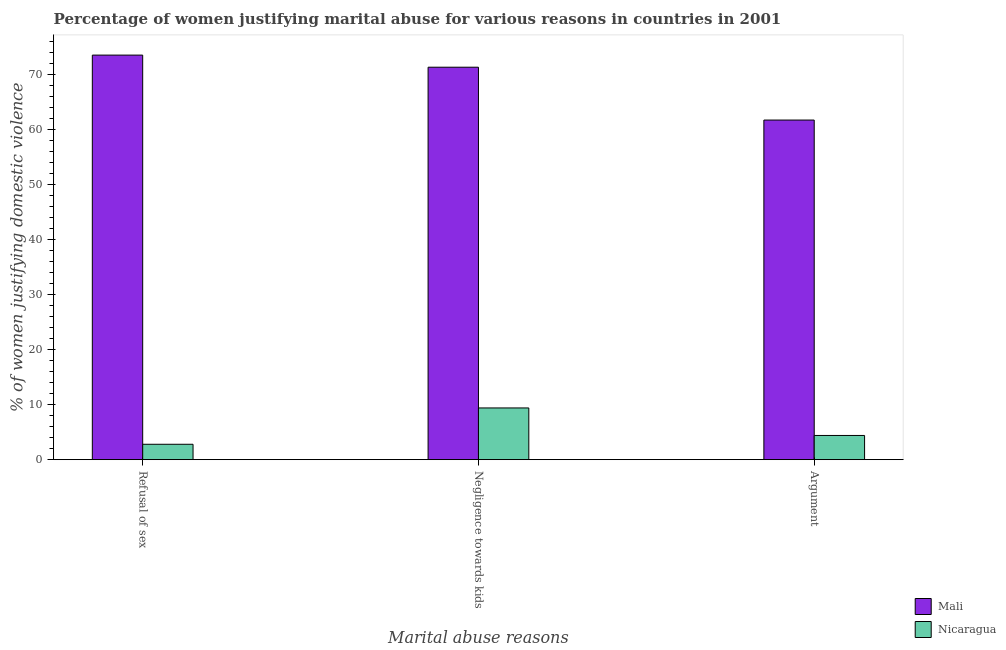Are the number of bars per tick equal to the number of legend labels?
Your response must be concise. Yes. How many bars are there on the 3rd tick from the right?
Provide a succinct answer. 2. What is the label of the 2nd group of bars from the left?
Your answer should be very brief. Negligence towards kids. What is the percentage of women justifying domestic violence due to negligence towards kids in Mali?
Your response must be concise. 71.3. Across all countries, what is the maximum percentage of women justifying domestic violence due to refusal of sex?
Your answer should be compact. 73.5. Across all countries, what is the minimum percentage of women justifying domestic violence due to arguments?
Keep it short and to the point. 4.4. In which country was the percentage of women justifying domestic violence due to refusal of sex maximum?
Provide a short and direct response. Mali. In which country was the percentage of women justifying domestic violence due to arguments minimum?
Your response must be concise. Nicaragua. What is the total percentage of women justifying domestic violence due to arguments in the graph?
Give a very brief answer. 66.1. What is the difference between the percentage of women justifying domestic violence due to negligence towards kids in Mali and that in Nicaragua?
Keep it short and to the point. 61.9. What is the difference between the percentage of women justifying domestic violence due to arguments in Mali and the percentage of women justifying domestic violence due to refusal of sex in Nicaragua?
Offer a terse response. 58.9. What is the average percentage of women justifying domestic violence due to negligence towards kids per country?
Give a very brief answer. 40.35. In how many countries, is the percentage of women justifying domestic violence due to negligence towards kids greater than 46 %?
Offer a terse response. 1. What is the ratio of the percentage of women justifying domestic violence due to arguments in Mali to that in Nicaragua?
Your answer should be compact. 14.02. What is the difference between the highest and the second highest percentage of women justifying domestic violence due to arguments?
Your answer should be compact. 57.3. What is the difference between the highest and the lowest percentage of women justifying domestic violence due to negligence towards kids?
Your response must be concise. 61.9. In how many countries, is the percentage of women justifying domestic violence due to refusal of sex greater than the average percentage of women justifying domestic violence due to refusal of sex taken over all countries?
Ensure brevity in your answer.  1. What does the 2nd bar from the left in Negligence towards kids represents?
Keep it short and to the point. Nicaragua. What does the 2nd bar from the right in Argument represents?
Your answer should be compact. Mali. Is it the case that in every country, the sum of the percentage of women justifying domestic violence due to refusal of sex and percentage of women justifying domestic violence due to negligence towards kids is greater than the percentage of women justifying domestic violence due to arguments?
Make the answer very short. Yes. How many countries are there in the graph?
Keep it short and to the point. 2. Does the graph contain grids?
Provide a short and direct response. No. Where does the legend appear in the graph?
Your answer should be compact. Bottom right. How are the legend labels stacked?
Keep it short and to the point. Vertical. What is the title of the graph?
Your response must be concise. Percentage of women justifying marital abuse for various reasons in countries in 2001. What is the label or title of the X-axis?
Make the answer very short. Marital abuse reasons. What is the label or title of the Y-axis?
Your answer should be very brief. % of women justifying domestic violence. What is the % of women justifying domestic violence of Mali in Refusal of sex?
Offer a terse response. 73.5. What is the % of women justifying domestic violence in Mali in Negligence towards kids?
Your response must be concise. 71.3. What is the % of women justifying domestic violence of Mali in Argument?
Your answer should be compact. 61.7. What is the % of women justifying domestic violence of Nicaragua in Argument?
Your response must be concise. 4.4. Across all Marital abuse reasons, what is the maximum % of women justifying domestic violence in Mali?
Keep it short and to the point. 73.5. Across all Marital abuse reasons, what is the minimum % of women justifying domestic violence in Mali?
Ensure brevity in your answer.  61.7. Across all Marital abuse reasons, what is the minimum % of women justifying domestic violence of Nicaragua?
Your answer should be compact. 2.8. What is the total % of women justifying domestic violence in Mali in the graph?
Offer a terse response. 206.5. What is the total % of women justifying domestic violence of Nicaragua in the graph?
Keep it short and to the point. 16.6. What is the difference between the % of women justifying domestic violence in Nicaragua in Refusal of sex and that in Argument?
Provide a succinct answer. -1.6. What is the difference between the % of women justifying domestic violence in Mali in Refusal of sex and the % of women justifying domestic violence in Nicaragua in Negligence towards kids?
Make the answer very short. 64.1. What is the difference between the % of women justifying domestic violence in Mali in Refusal of sex and the % of women justifying domestic violence in Nicaragua in Argument?
Give a very brief answer. 69.1. What is the difference between the % of women justifying domestic violence in Mali in Negligence towards kids and the % of women justifying domestic violence in Nicaragua in Argument?
Provide a succinct answer. 66.9. What is the average % of women justifying domestic violence in Mali per Marital abuse reasons?
Provide a short and direct response. 68.83. What is the average % of women justifying domestic violence in Nicaragua per Marital abuse reasons?
Keep it short and to the point. 5.53. What is the difference between the % of women justifying domestic violence of Mali and % of women justifying domestic violence of Nicaragua in Refusal of sex?
Make the answer very short. 70.7. What is the difference between the % of women justifying domestic violence in Mali and % of women justifying domestic violence in Nicaragua in Negligence towards kids?
Your answer should be very brief. 61.9. What is the difference between the % of women justifying domestic violence in Mali and % of women justifying domestic violence in Nicaragua in Argument?
Provide a short and direct response. 57.3. What is the ratio of the % of women justifying domestic violence in Mali in Refusal of sex to that in Negligence towards kids?
Keep it short and to the point. 1.03. What is the ratio of the % of women justifying domestic violence of Nicaragua in Refusal of sex to that in Negligence towards kids?
Offer a terse response. 0.3. What is the ratio of the % of women justifying domestic violence in Mali in Refusal of sex to that in Argument?
Your response must be concise. 1.19. What is the ratio of the % of women justifying domestic violence in Nicaragua in Refusal of sex to that in Argument?
Your answer should be very brief. 0.64. What is the ratio of the % of women justifying domestic violence in Mali in Negligence towards kids to that in Argument?
Give a very brief answer. 1.16. What is the ratio of the % of women justifying domestic violence of Nicaragua in Negligence towards kids to that in Argument?
Keep it short and to the point. 2.14. What is the difference between the highest and the second highest % of women justifying domestic violence of Nicaragua?
Offer a terse response. 5. What is the difference between the highest and the lowest % of women justifying domestic violence of Mali?
Ensure brevity in your answer.  11.8. 